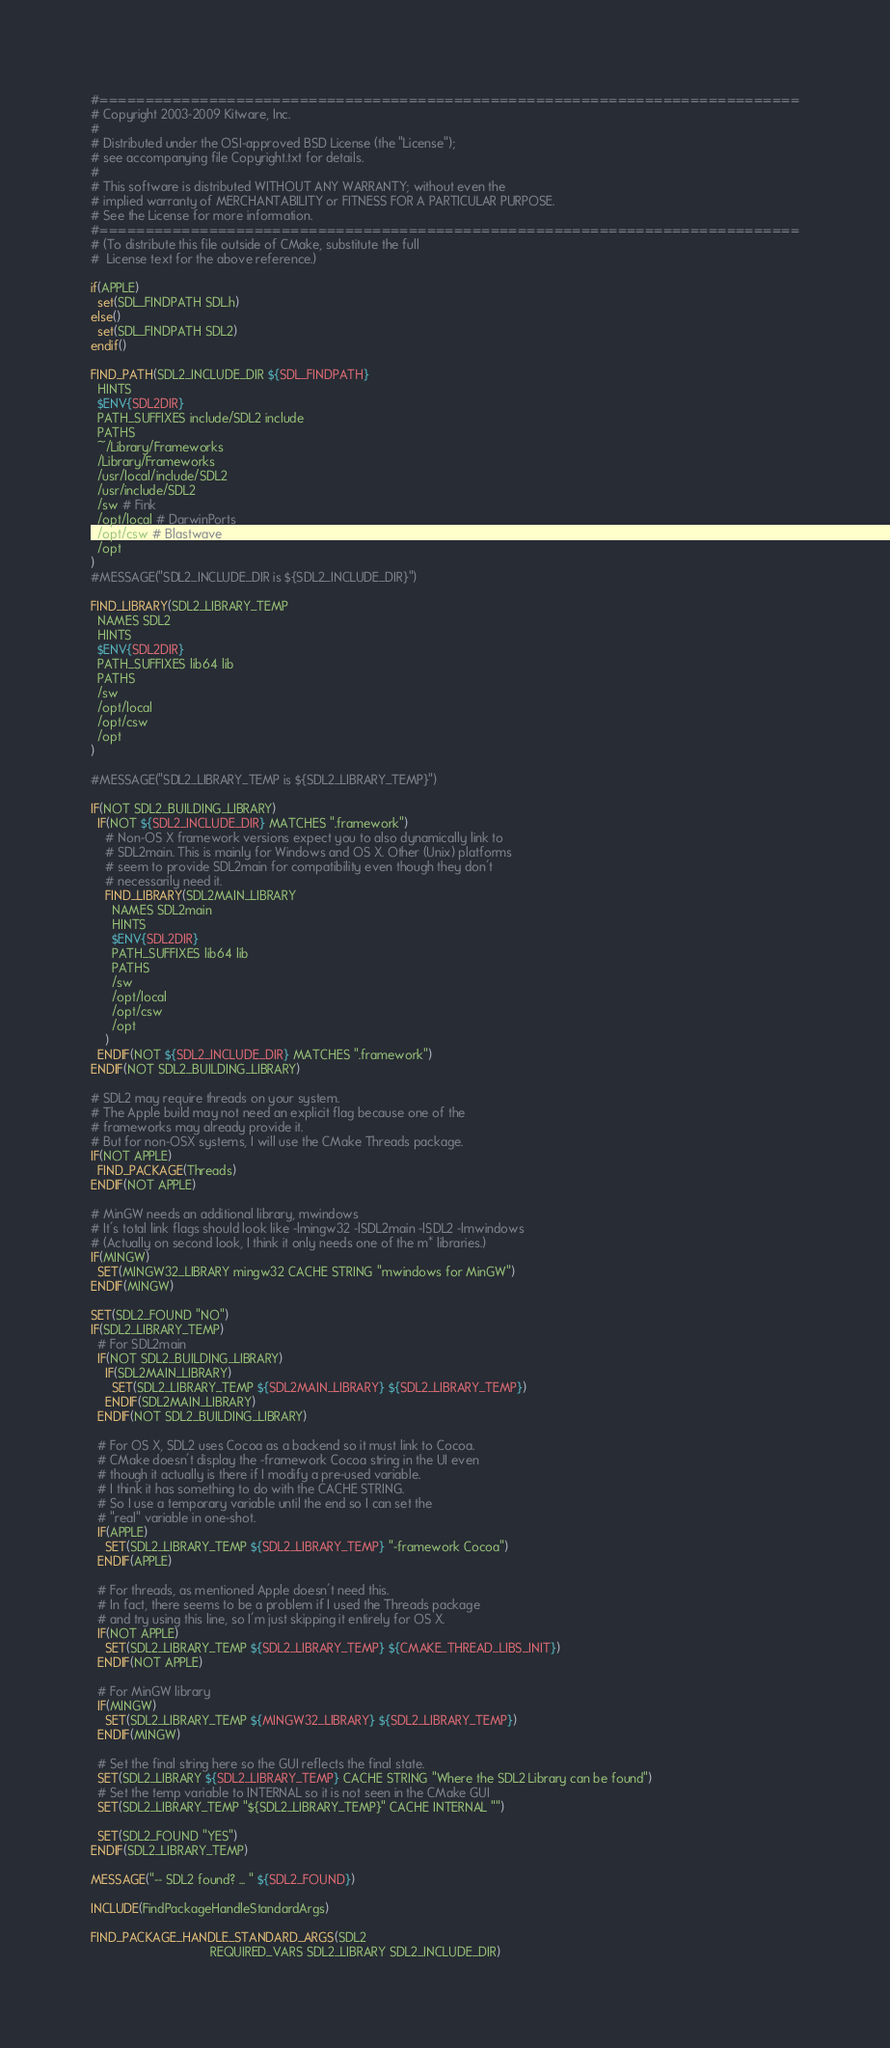Convert code to text. <code><loc_0><loc_0><loc_500><loc_500><_CMake_>#=============================================================================
# Copyright 2003-2009 Kitware, Inc.
#
# Distributed under the OSI-approved BSD License (the "License");
# see accompanying file Copyright.txt for details.
#
# This software is distributed WITHOUT ANY WARRANTY; without even the
# implied warranty of MERCHANTABILITY or FITNESS FOR A PARTICULAR PURPOSE.
# See the License for more information.
#=============================================================================
# (To distribute this file outside of CMake, substitute the full
#  License text for the above reference.)

if(APPLE)
  set(SDL_FINDPATH SDL.h)
else()
  set(SDL_FINDPATH SDL2)
endif()

FIND_PATH(SDL2_INCLUDE_DIR ${SDL_FINDPATH}
  HINTS
  $ENV{SDL2DIR}
  PATH_SUFFIXES include/SDL2 include
  PATHS
  ~/Library/Frameworks
  /Library/Frameworks
  /usr/local/include/SDL2
  /usr/include/SDL2
  /sw # Fink
  /opt/local # DarwinPorts
  /opt/csw # Blastwave
  /opt
)
#MESSAGE("SDL2_INCLUDE_DIR is ${SDL2_INCLUDE_DIR}")

FIND_LIBRARY(SDL2_LIBRARY_TEMP
  NAMES SDL2
  HINTS
  $ENV{SDL2DIR}
  PATH_SUFFIXES lib64 lib
  PATHS
  /sw
  /opt/local
  /opt/csw
  /opt
)

#MESSAGE("SDL2_LIBRARY_TEMP is ${SDL2_LIBRARY_TEMP}")

IF(NOT SDL2_BUILDING_LIBRARY)
  IF(NOT ${SDL2_INCLUDE_DIR} MATCHES ".framework")
    # Non-OS X framework versions expect you to also dynamically link to
    # SDL2main. This is mainly for Windows and OS X. Other (Unix) platforms
    # seem to provide SDL2main for compatibility even though they don't
    # necessarily need it.
    FIND_LIBRARY(SDL2MAIN_LIBRARY
      NAMES SDL2main
      HINTS
      $ENV{SDL2DIR}
      PATH_SUFFIXES lib64 lib
      PATHS
      /sw
      /opt/local
      /opt/csw
      /opt
    )
  ENDIF(NOT ${SDL2_INCLUDE_DIR} MATCHES ".framework")
ENDIF(NOT SDL2_BUILDING_LIBRARY)

# SDL2 may require threads on your system.
# The Apple build may not need an explicit flag because one of the
# frameworks may already provide it.
# But for non-OSX systems, I will use the CMake Threads package.
IF(NOT APPLE)
  FIND_PACKAGE(Threads)
ENDIF(NOT APPLE)

# MinGW needs an additional library, mwindows
# It's total link flags should look like -lmingw32 -lSDL2main -lSDL2 -lmwindows
# (Actually on second look, I think it only needs one of the m* libraries.)
IF(MINGW)
  SET(MINGW32_LIBRARY mingw32 CACHE STRING "mwindows for MinGW")
ENDIF(MINGW)

SET(SDL2_FOUND "NO")
IF(SDL2_LIBRARY_TEMP)
  # For SDL2main
  IF(NOT SDL2_BUILDING_LIBRARY)
    IF(SDL2MAIN_LIBRARY)
      SET(SDL2_LIBRARY_TEMP ${SDL2MAIN_LIBRARY} ${SDL2_LIBRARY_TEMP})
    ENDIF(SDL2MAIN_LIBRARY)
  ENDIF(NOT SDL2_BUILDING_LIBRARY)

  # For OS X, SDL2 uses Cocoa as a backend so it must link to Cocoa.
  # CMake doesn't display the -framework Cocoa string in the UI even
  # though it actually is there if I modify a pre-used variable.
  # I think it has something to do with the CACHE STRING.
  # So I use a temporary variable until the end so I can set the
  # "real" variable in one-shot.
  IF(APPLE)
    SET(SDL2_LIBRARY_TEMP ${SDL2_LIBRARY_TEMP} "-framework Cocoa")
  ENDIF(APPLE)

  # For threads, as mentioned Apple doesn't need this.
  # In fact, there seems to be a problem if I used the Threads package
  # and try using this line, so I'm just skipping it entirely for OS X.
  IF(NOT APPLE)
    SET(SDL2_LIBRARY_TEMP ${SDL2_LIBRARY_TEMP} ${CMAKE_THREAD_LIBS_INIT})
  ENDIF(NOT APPLE)

  # For MinGW library
  IF(MINGW)
    SET(SDL2_LIBRARY_TEMP ${MINGW32_LIBRARY} ${SDL2_LIBRARY_TEMP})
  ENDIF(MINGW)

  # Set the final string here so the GUI reflects the final state.
  SET(SDL2_LIBRARY ${SDL2_LIBRARY_TEMP} CACHE STRING "Where the SDL2 Library can be found")
  # Set the temp variable to INTERNAL so it is not seen in the CMake GUI
  SET(SDL2_LIBRARY_TEMP "${SDL2_LIBRARY_TEMP}" CACHE INTERNAL "")

  SET(SDL2_FOUND "YES")
ENDIF(SDL2_LIBRARY_TEMP)

MESSAGE("-- SDL2 found? ... " ${SDL2_FOUND})

INCLUDE(FindPackageHandleStandardArgs)

FIND_PACKAGE_HANDLE_STANDARD_ARGS(SDL2
                                  REQUIRED_VARS SDL2_LIBRARY SDL2_INCLUDE_DIR)
</code> 